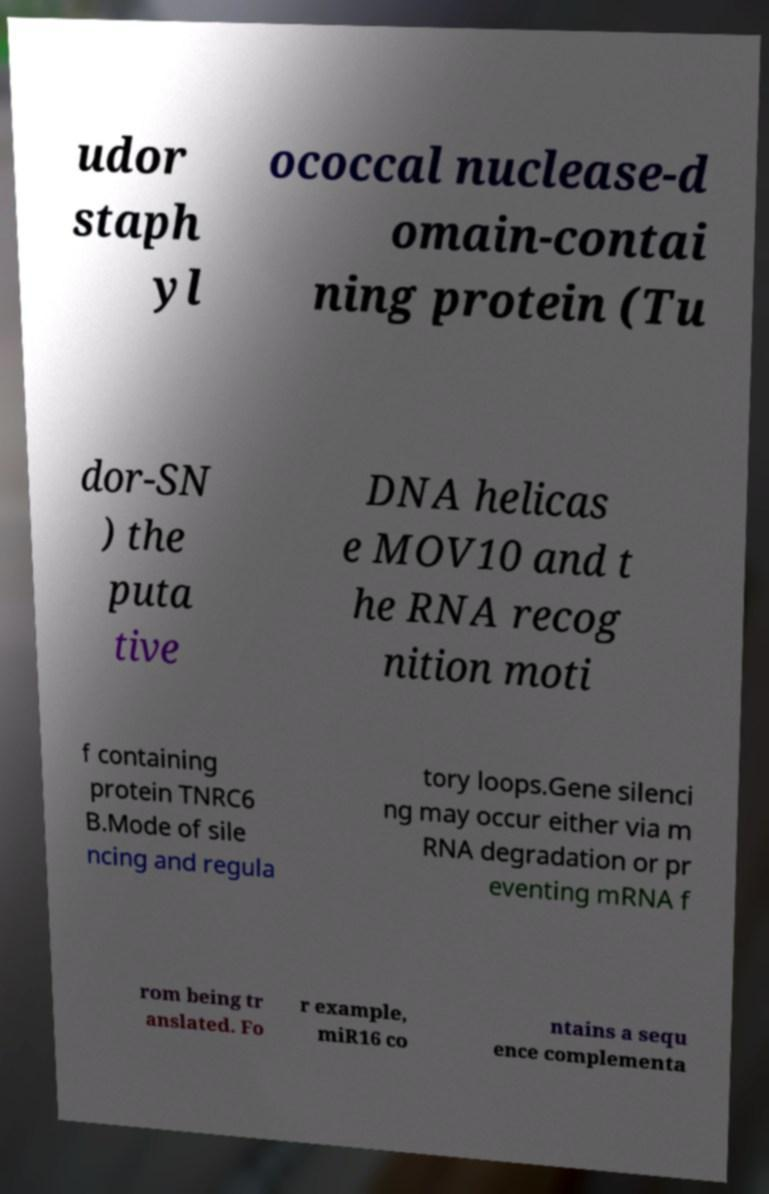Please identify and transcribe the text found in this image. udor staph yl ococcal nuclease-d omain-contai ning protein (Tu dor-SN ) the puta tive DNA helicas e MOV10 and t he RNA recog nition moti f containing protein TNRC6 B.Mode of sile ncing and regula tory loops.Gene silenci ng may occur either via m RNA degradation or pr eventing mRNA f rom being tr anslated. Fo r example, miR16 co ntains a sequ ence complementa 